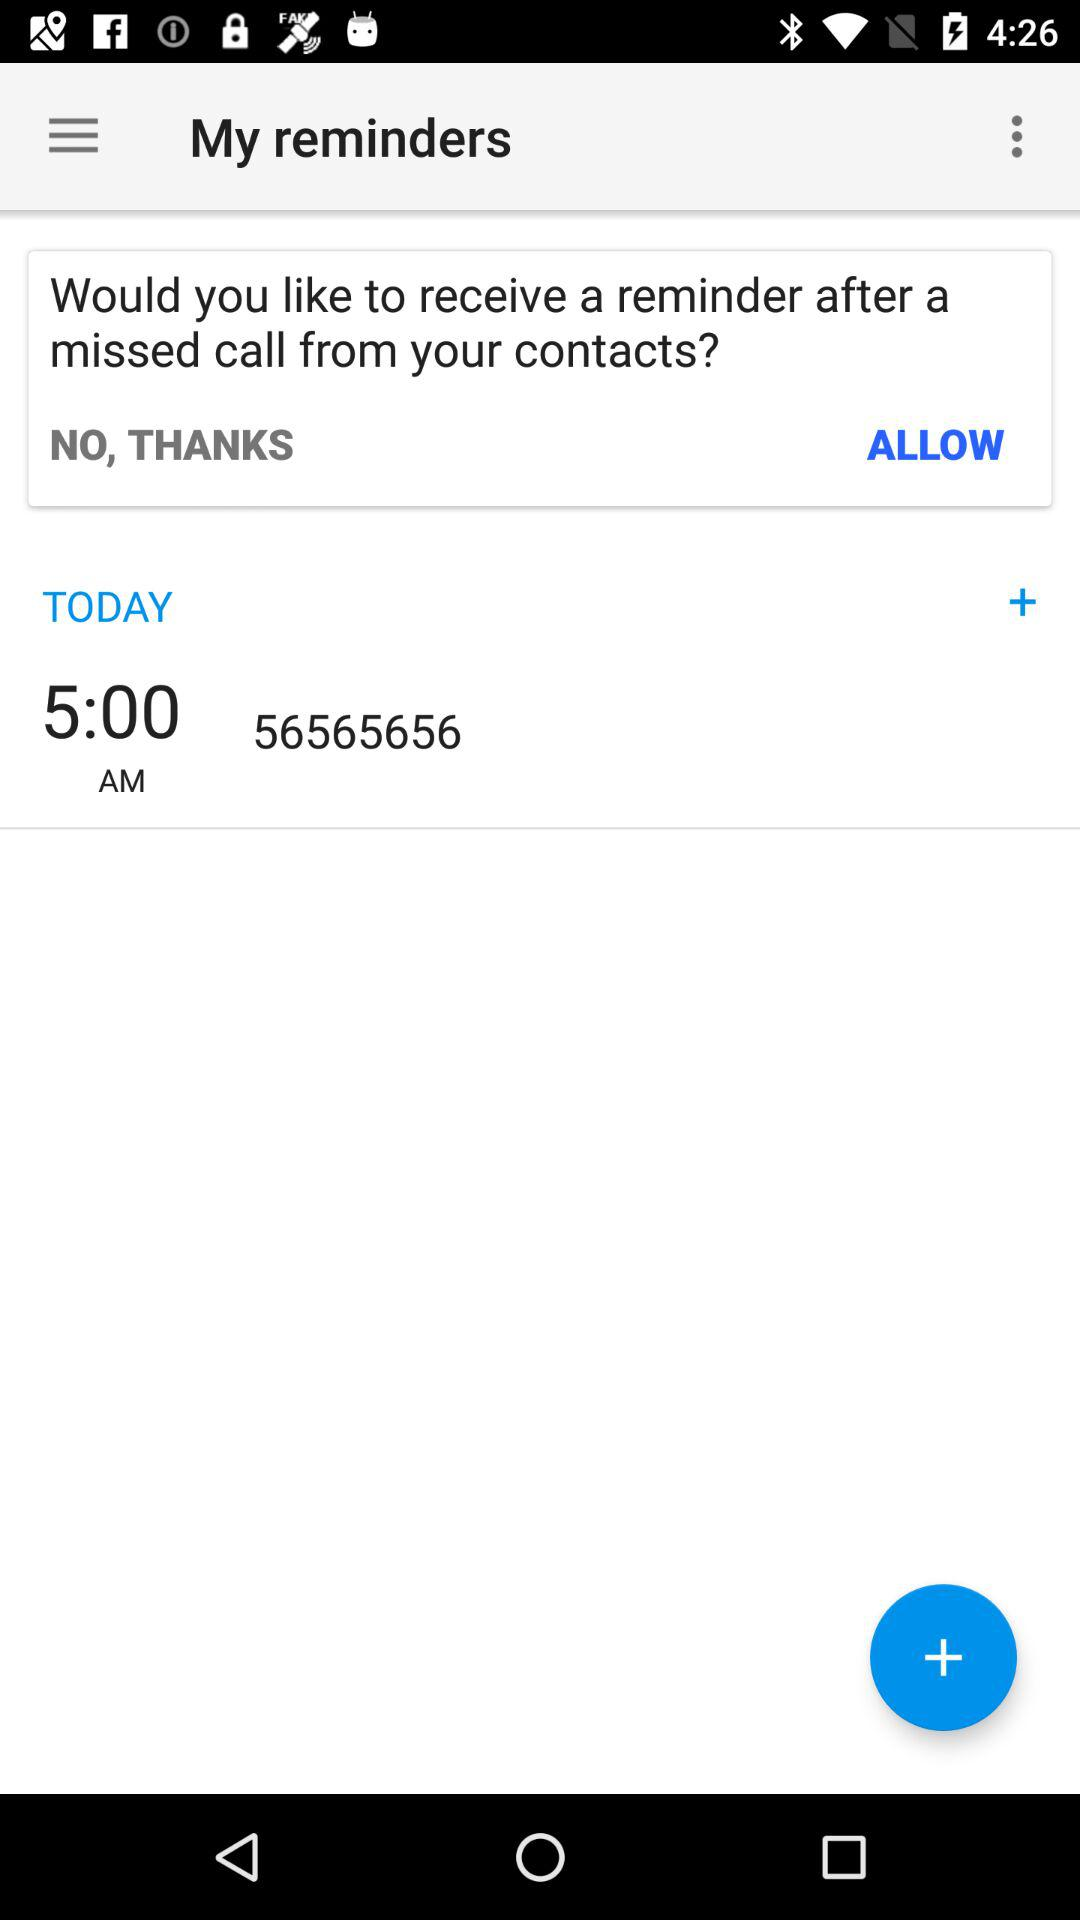What is the time of the reminder? The time of the reminder is 5:00 AM. 